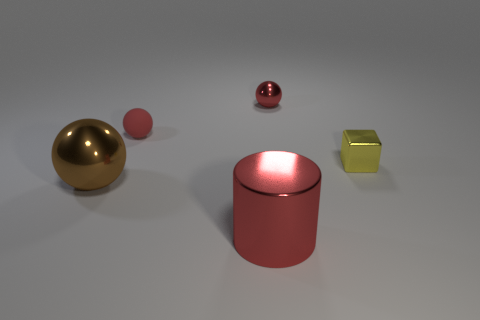There is another metallic thing that is the same shape as the big brown thing; what is its color? red 